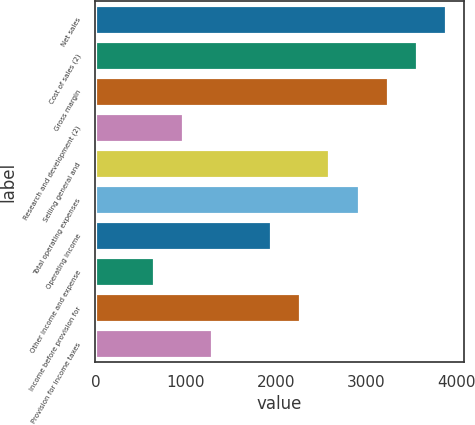Convert chart to OTSL. <chart><loc_0><loc_0><loc_500><loc_500><bar_chart><fcel>Net sales<fcel>Cost of sales (2)<fcel>Gross margin<fcel>Research and development (2)<fcel>Selling general and<fcel>Total operating expenses<fcel>Operating income<fcel>Other income and expense<fcel>Income before provision for<fcel>Provision for income taxes<nl><fcel>3891.58<fcel>3567.31<fcel>3243.04<fcel>973.15<fcel>2594.5<fcel>2918.77<fcel>1945.96<fcel>648.88<fcel>2270.23<fcel>1297.42<nl></chart> 